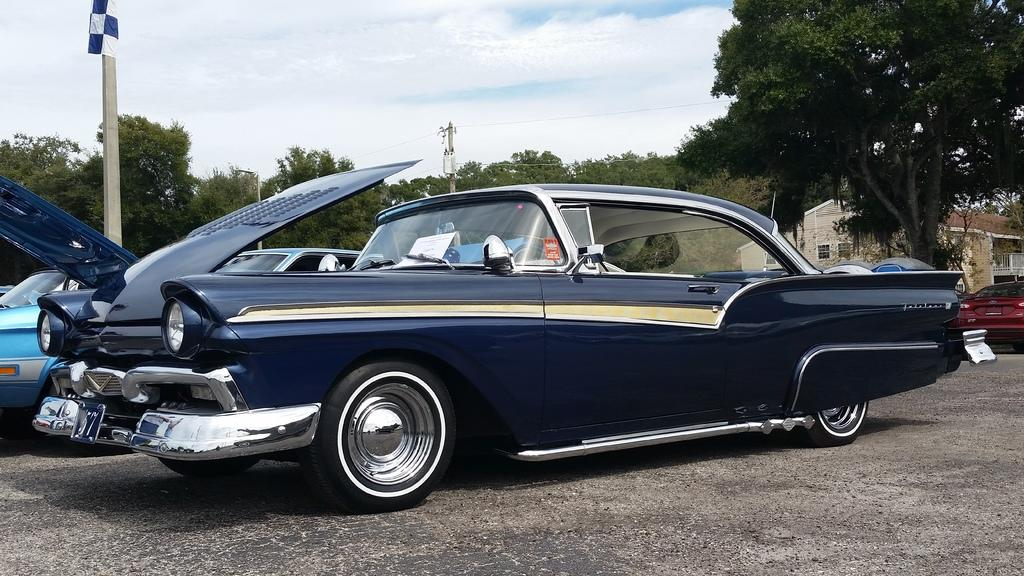What type of vehicles are on the ground in the image? There are cars on the ground in the image. What structures can be seen in the image? There are buildings visible in the image. What is attached to the pole in the image? There is a flag on a pole in the image. What else can be seen on the pole in the image? There is an utility pole with wires in the image. What is the condition of the sky in the image? The sky is visible in the image, and it appears to be cloudy. What type of class is being taught in the image? There is no class present in the image. --- Facts: 1. There is a person in the image. 2. The person is wearing a hat. 3. The person is holding a book. 4. There is a table in the image. 5. There is a chair in the image. Absurd Topics: elephant, parrot, monkey Conversation: Who or what is present in the image? There is a person in the image. What is the person wearing in the image? The person is wearing a hat in the image. What is the person holding in the image? The person is holding a book in the image. What type of furniture is present in the image? There is a table and a chair in the image. Reasoning: Let's think step by step in order to produce the conversation. We start by identifying the main subject of the image, which is the person. Next, we describe specific features of the person, such as the hat they are wearing. Then, we observe the actions of the person, noting that they are holding a book. Finally, we describe the furniture present in the image, which includes a table and a chair. Absurd Question/Answer: What type of elephant can be seen in the image? There is no elephant present in the image. --- Facts: 1. There is a dog in the image. 2. The dog is sitting on a rug. 3. The dog has a collar around its neck. 4. There is a bowl of water next to the dog. 5. There is a window in the background of the image. Absurd Topics: unicorn, mermaid, dragon Conversation: What type of animal is present in the image? There is a dog in the image. What is the dog doing in the image? The dog is sitting on a rug in the image. Does the dog have any accessories in the image? Yes, the dog has a collar around its neck in the image. What is located next to the dog in the image? There is a bowl of water next to the dog in the image. What can be seen in the background of the image? There is a window in the background of the image. Reasoning 